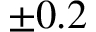<formula> <loc_0><loc_0><loc_500><loc_500>\pm 0 . 2</formula> 